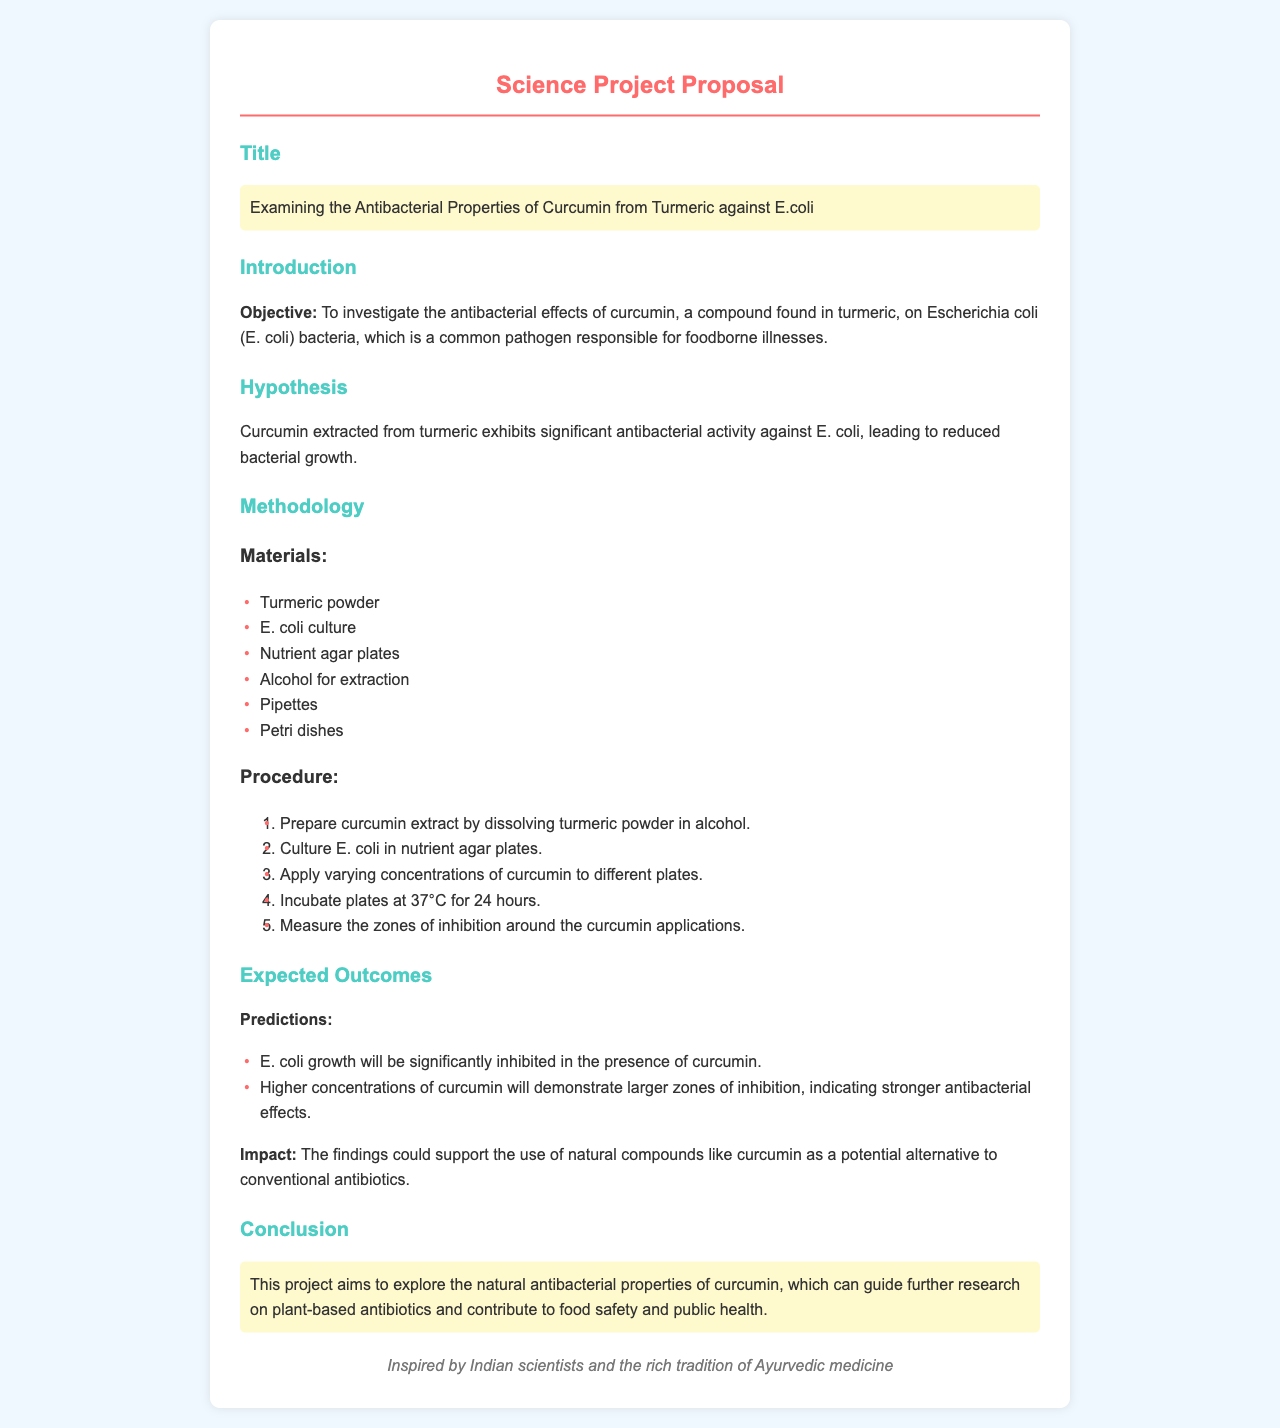What is the project title? The title of the project is a key piece of information presented prominently in the document.
Answer: Examining the Antibacterial Properties of Curcumin from Turmeric against E.coli What is the objective of the project? The objective is stated clearly in the introduction section and relates to the overall goal of the research.
Answer: To investigate the antibacterial effects of curcumin on Escherichia coli What are the first two materials listed? The materials section lists all items needed for the experiment in a specific order.
Answer: Turmeric powder, E. coli culture How many steps are in the procedure? The procedure outlines a series of steps necessary to complete the experiment, which can be counted.
Answer: 5 What is the expected impact of the findings? The expected impact highlights the significance of the research and what it may contribute to the field.
Answer: Support the use of natural compounds like curcumin as a potential alternative to conventional antibiotics What does the hypothesis state? The hypothesis is a formal statement predicting the outcome of the experiment and is located in a dedicated section.
Answer: Curcumin extracted from turmeric exhibits significant antibacterial activity against E. coli How does curcumin affect E. coli according to the expected outcomes? The expected outcomes part provides predictions specifically related to the expected interactions between curcumin and E. coli.
Answer: E. coli growth will be significantly inhibited In which year could this study contribute to food safety? The conclusion suggests the broader implications of the research.
Answer: 2023 Who is the inspiration behind the project? The footer credits the influence that inspired the work detailed in the proposal.
Answer: Indian scientists 